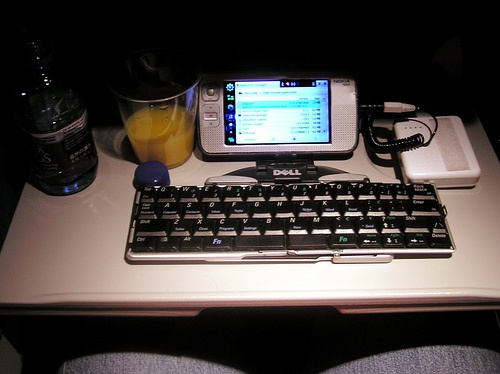Describe the objects in this image and their specific colors. I can see keyboard in black, gray, white, and darkgray tones, cell phone in black, white, darkgray, and lightblue tones, cup in black, olive, and maroon tones, and bottle in black, gray, and navy tones in this image. 